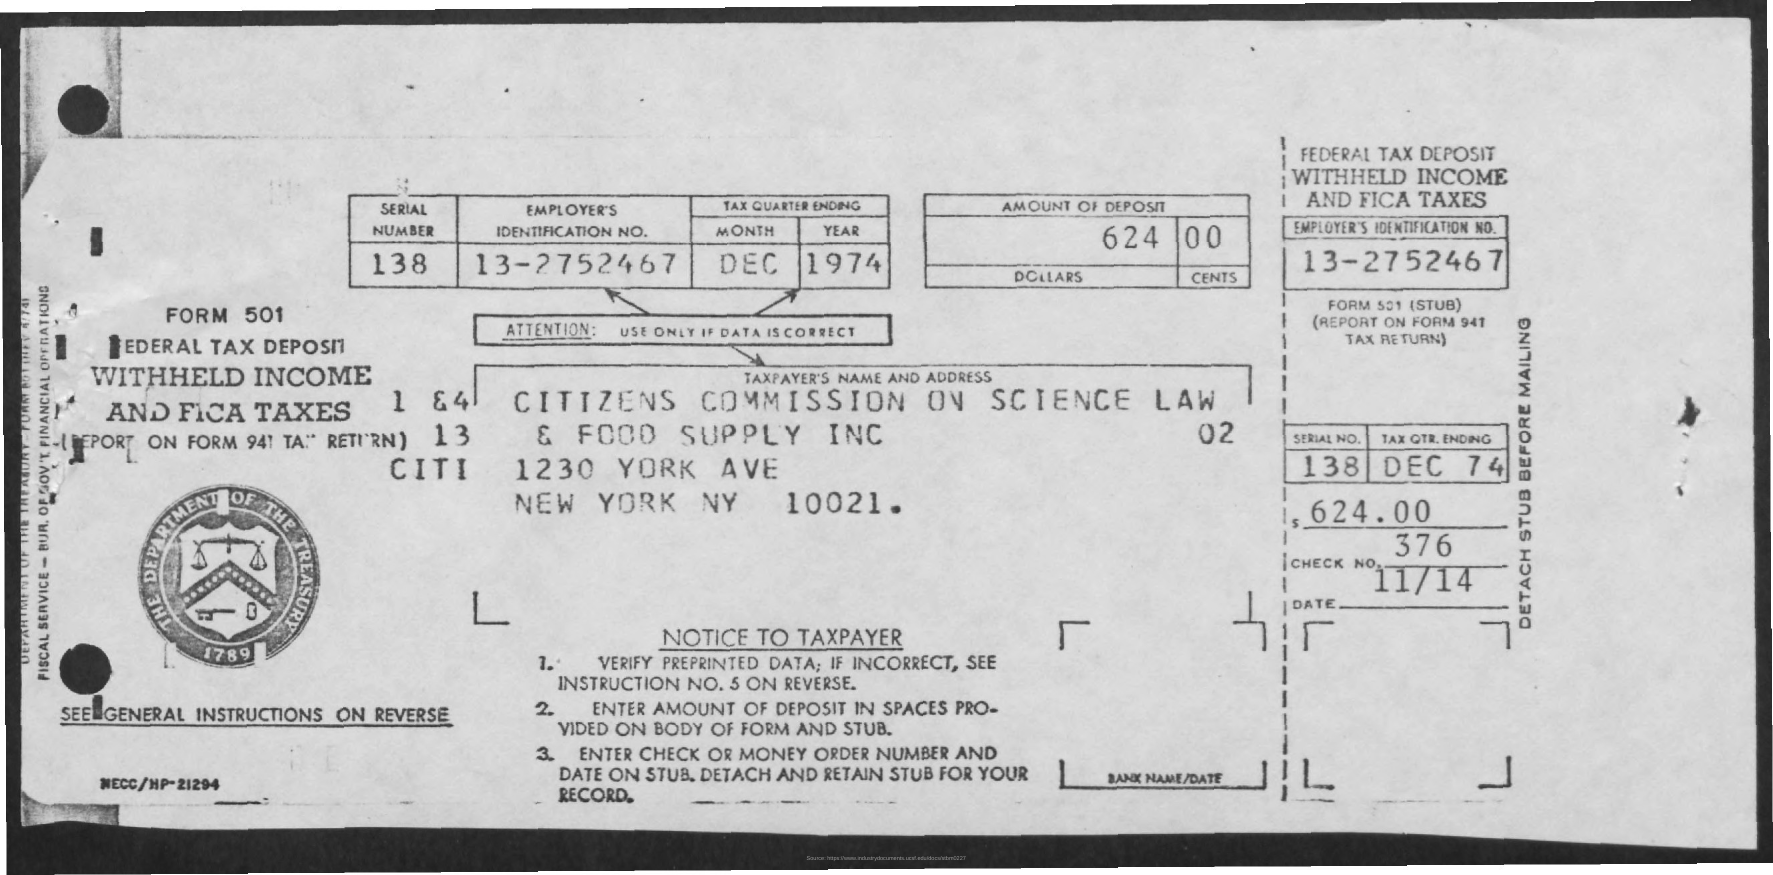Can you tell me what this document is used for? This image shows a Form 501, which is a federal tax deposit form used to report and pay withheld income and FICA taxes to the Internal Revenue Service (IRS). It is a part of the employer's payroll tax responsibilities. 